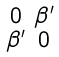Convert formula to latex. <formula><loc_0><loc_0><loc_500><loc_500>\begin{smallmatrix} 0 & \beta ^ { \prime } \\ \beta ^ { \prime } & 0 \end{smallmatrix}</formula> 